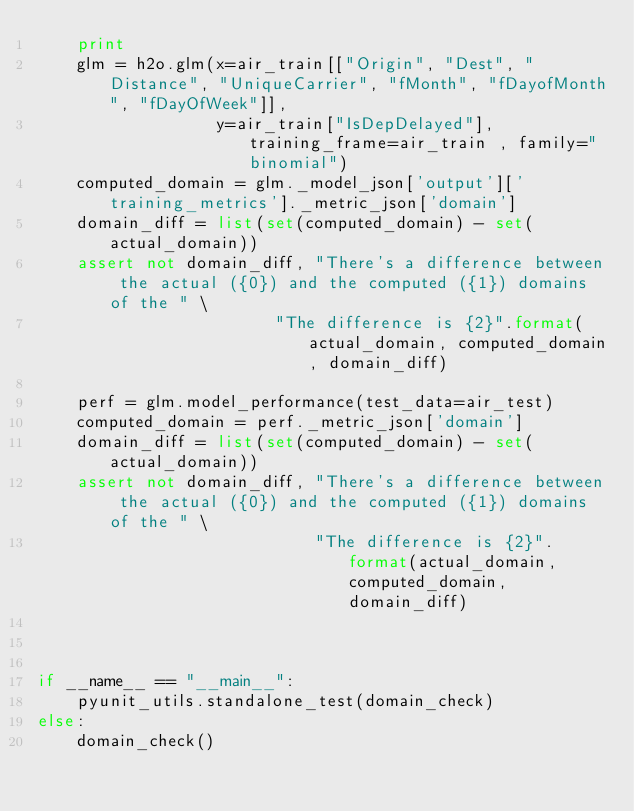Convert code to text. <code><loc_0><loc_0><loc_500><loc_500><_Python_>    print
    glm = h2o.glm(x=air_train[["Origin", "Dest", "Distance", "UniqueCarrier", "fMonth", "fDayofMonth", "fDayOfWeek"]],
                  y=air_train["IsDepDelayed"], training_frame=air_train , family="binomial")
    computed_domain = glm._model_json['output']['training_metrics']._metric_json['domain']
    domain_diff = list(set(computed_domain) - set(actual_domain))
    assert not domain_diff, "There's a difference between the actual ({0}) and the computed ({1}) domains of the " \
                        "The difference is {2}".format(actual_domain, computed_domain, domain_diff)

    perf = glm.model_performance(test_data=air_test)
    computed_domain = perf._metric_json['domain']
    domain_diff = list(set(computed_domain) - set(actual_domain))
    assert not domain_diff, "There's a difference between the actual ({0}) and the computed ({1}) domains of the " \
                            "The difference is {2}".format(actual_domain, computed_domain, domain_diff)



if __name__ == "__main__":
    pyunit_utils.standalone_test(domain_check)
else:
    domain_check()
</code> 